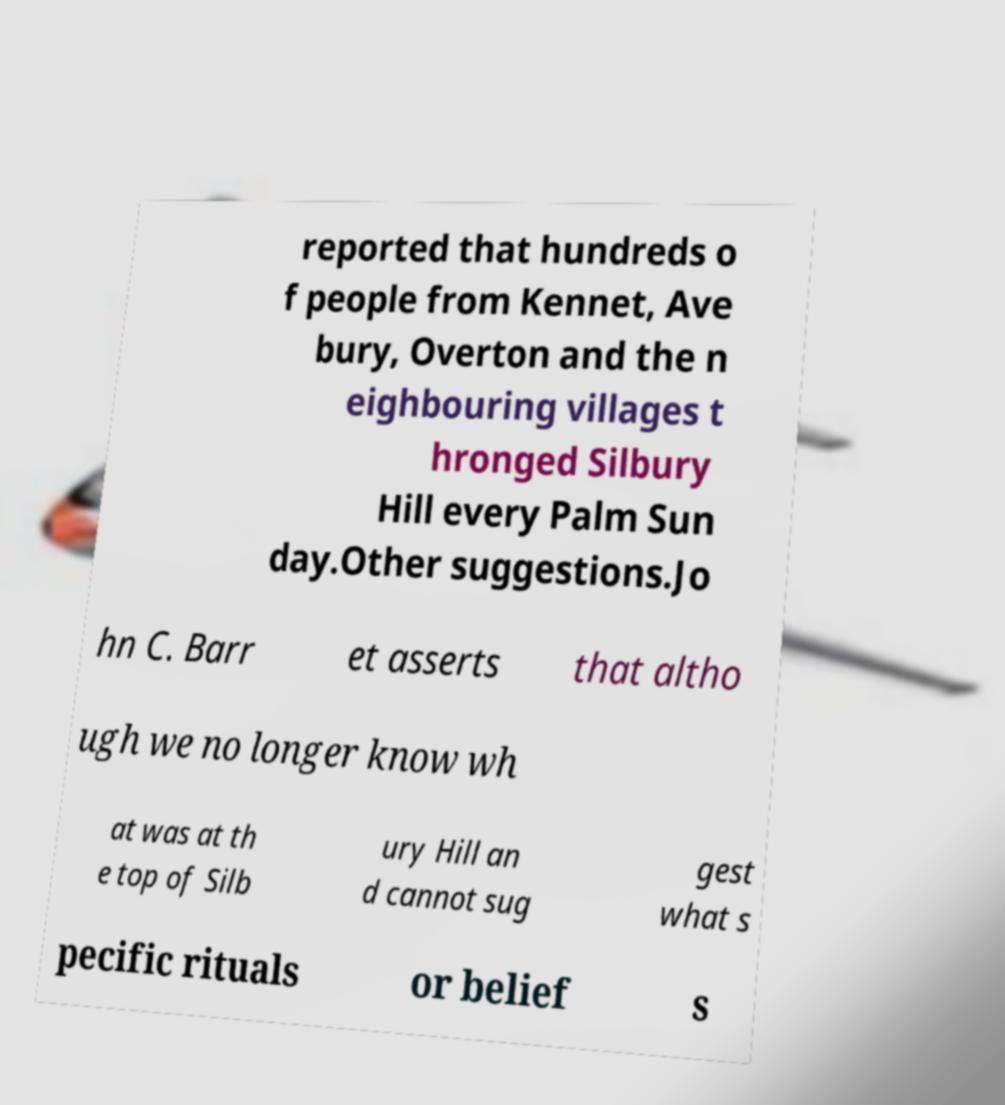Can you read and provide the text displayed in the image?This photo seems to have some interesting text. Can you extract and type it out for me? reported that hundreds o f people from Kennet, Ave bury, Overton and the n eighbouring villages t hronged Silbury Hill every Palm Sun day.Other suggestions.Jo hn C. Barr et asserts that altho ugh we no longer know wh at was at th e top of Silb ury Hill an d cannot sug gest what s pecific rituals or belief s 